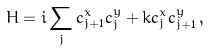Convert formula to latex. <formula><loc_0><loc_0><loc_500><loc_500>H = i \sum _ { j } c ^ { x } _ { j + 1 } c ^ { y } _ { j } + k c ^ { x } _ { j } c ^ { y } _ { j + 1 } \, ,</formula> 